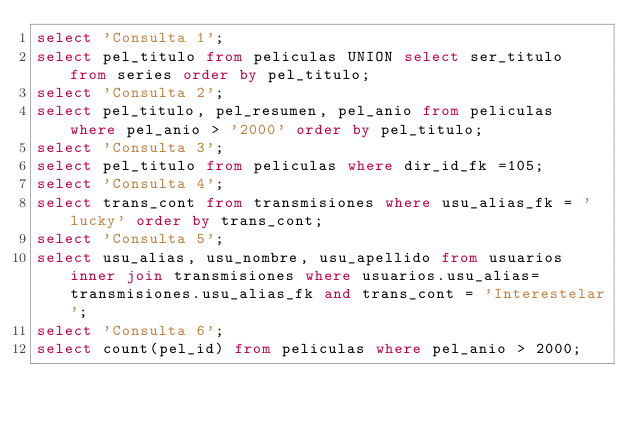Convert code to text. <code><loc_0><loc_0><loc_500><loc_500><_SQL_>select 'Consulta 1';
select pel_titulo from peliculas UNION select ser_titulo from series order by pel_titulo;
select 'Consulta 2';
select pel_titulo, pel_resumen, pel_anio from peliculas where pel_anio > '2000' order by pel_titulo;
select 'Consulta 3';
select pel_titulo from peliculas where dir_id_fk =105;
select 'Consulta 4';
select trans_cont from transmisiones where usu_alias_fk = 'lucky' order by trans_cont;
select 'Consulta 5';
select usu_alias, usu_nombre, usu_apellido from usuarios inner join transmisiones where usuarios.usu_alias=transmisiones.usu_alias_fk and trans_cont = 'Interestelar';
select 'Consulta 6';
select count(pel_id) from peliculas where pel_anio > 2000;</code> 